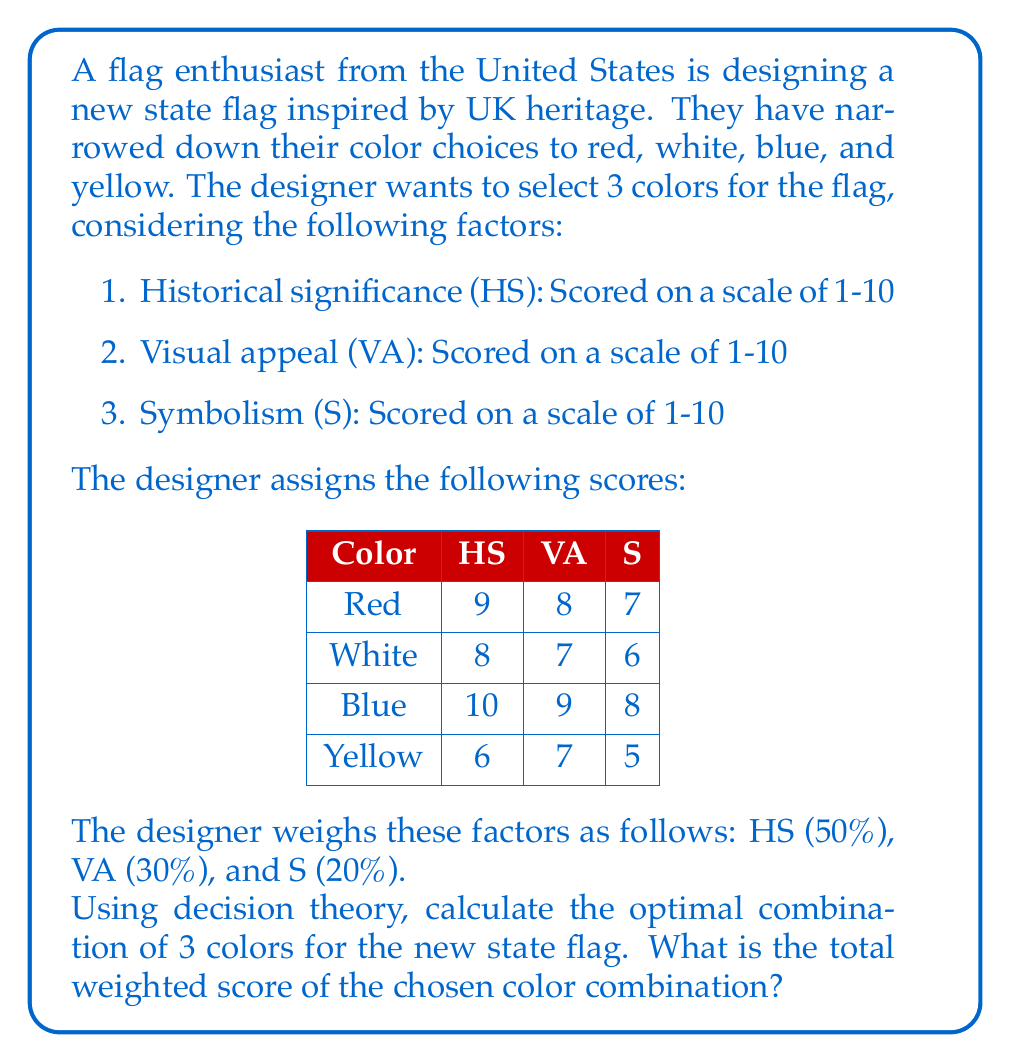Give your solution to this math problem. To solve this problem, we'll use a decision matrix approach:

1. Calculate the weighted score for each color:
   For each color, we'll use the formula:
   $$ \text{Weighted Score} = 0.5 \times \text{HS} + 0.3 \times \text{VA} + 0.2 \times \text{S} $$

   Red: $0.5 \times 9 + 0.3 \times 8 + 0.2 \times 7 = 8.3$
   White: $0.5 \times 8 + 0.3 \times 7 + 0.2 \times 6 = 7.3$
   Blue: $0.5 \times 10 + 0.3 \times 9 + 0.2 \times 8 = 9.3$
   Yellow: $0.5 \times 6 + 0.3 \times 7 + 0.2 \times 5 = 6.1$

2. Rank the colors based on their weighted scores:
   1. Blue (9.3)
   2. Red (8.3)
   3. White (7.3)
   4. Yellow (6.1)

3. Select the top 3 colors:
   Blue, Red, and White

4. Calculate the total weighted score of the chosen combination:
   $$ \text{Total Score} = 9.3 + 8.3 + 7.3 = 24.9 $$

Therefore, the optimal combination of colors for the new state flag is Blue, Red, and White, with a total weighted score of 24.9.
Answer: The optimal combination of 3 colors for the new state flag is Blue, Red, and White, with a total weighted score of 24.9. 